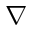Convert formula to latex. <formula><loc_0><loc_0><loc_500><loc_500>\nabla</formula> 